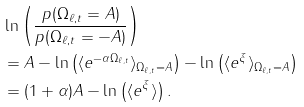Convert formula to latex. <formula><loc_0><loc_0><loc_500><loc_500>& \ln \left ( \frac { p ( \Omega _ { \ell , t } = A ) } { p ( \Omega _ { \ell , t } = - A ) } \right ) \\ & = A - \ln \left ( \langle e ^ { - \alpha \Omega _ { \ell , t } } \rangle _ { \Omega _ { \ell , t } = A } \right ) - \ln \left ( \langle e ^ { \xi } \rangle _ { \Omega _ { \ell , t } = A } \right ) \\ & = ( 1 + \alpha ) A - \ln \left ( \langle e ^ { \xi } \rangle \right ) .</formula> 